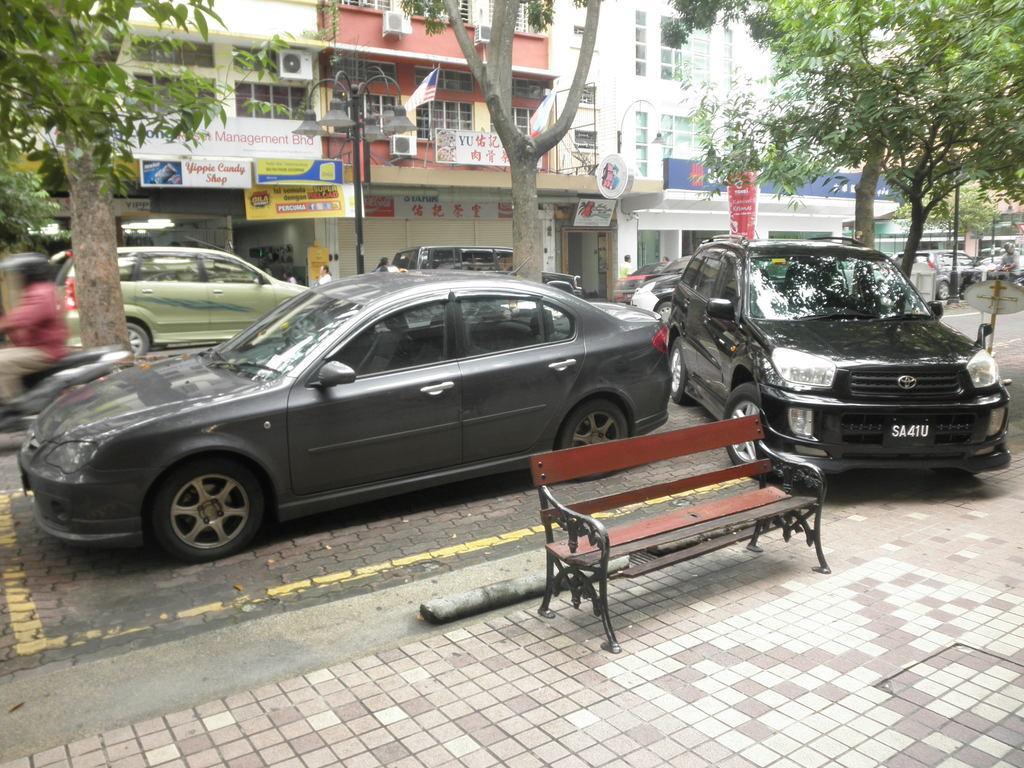Please provide a concise description of this image. Here we can see buildings, hoardings and store. These are trees. We can see few vehicles on the road and a man is riding a bike wearing a helmet. This is an empty bench. 